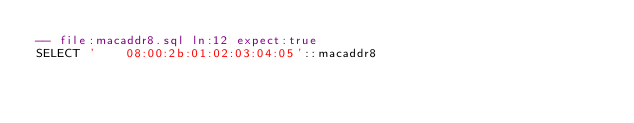Convert code to text. <code><loc_0><loc_0><loc_500><loc_500><_SQL_>-- file:macaddr8.sql ln:12 expect:true
SELECT '    08:00:2b:01:02:03:04:05'::macaddr8
</code> 